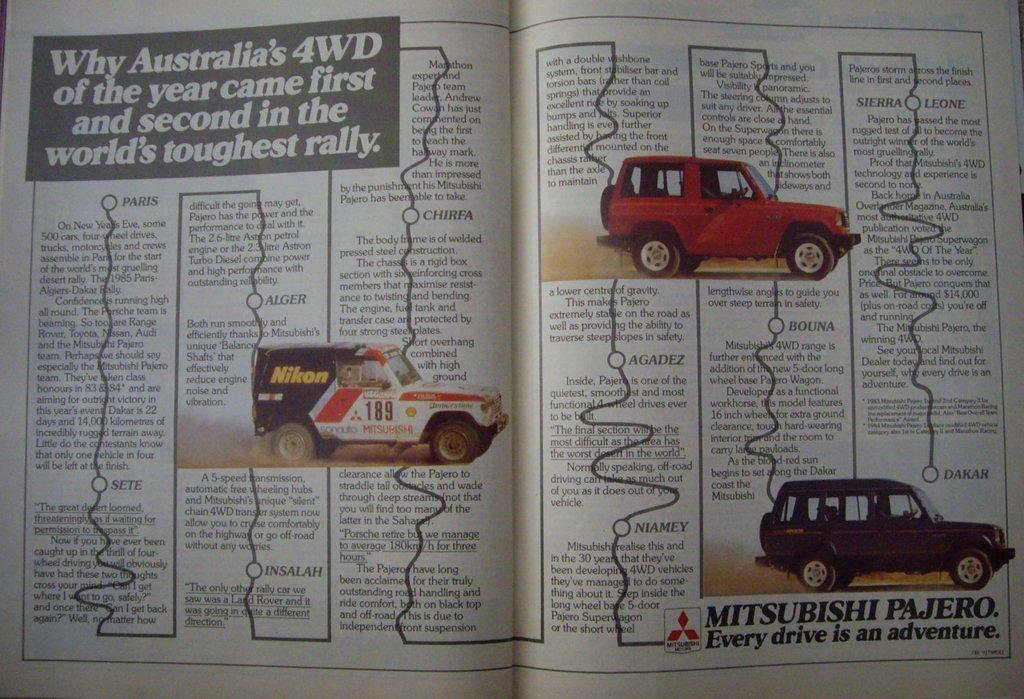What is present in the image related to reading material? There is a book in the image. How is the book positioned in the image? The book is open. What can be found on the pages of the book? There is text and vehicles depicted on the pages of the book. Is there any branding or identification on the pages of the book? Yes, there is a logo on the pages of the book. Can you see a rat running along the edge of the book in the image? There is no rat present in the image, nor is there any indication of a rat running along the edge of the book. 